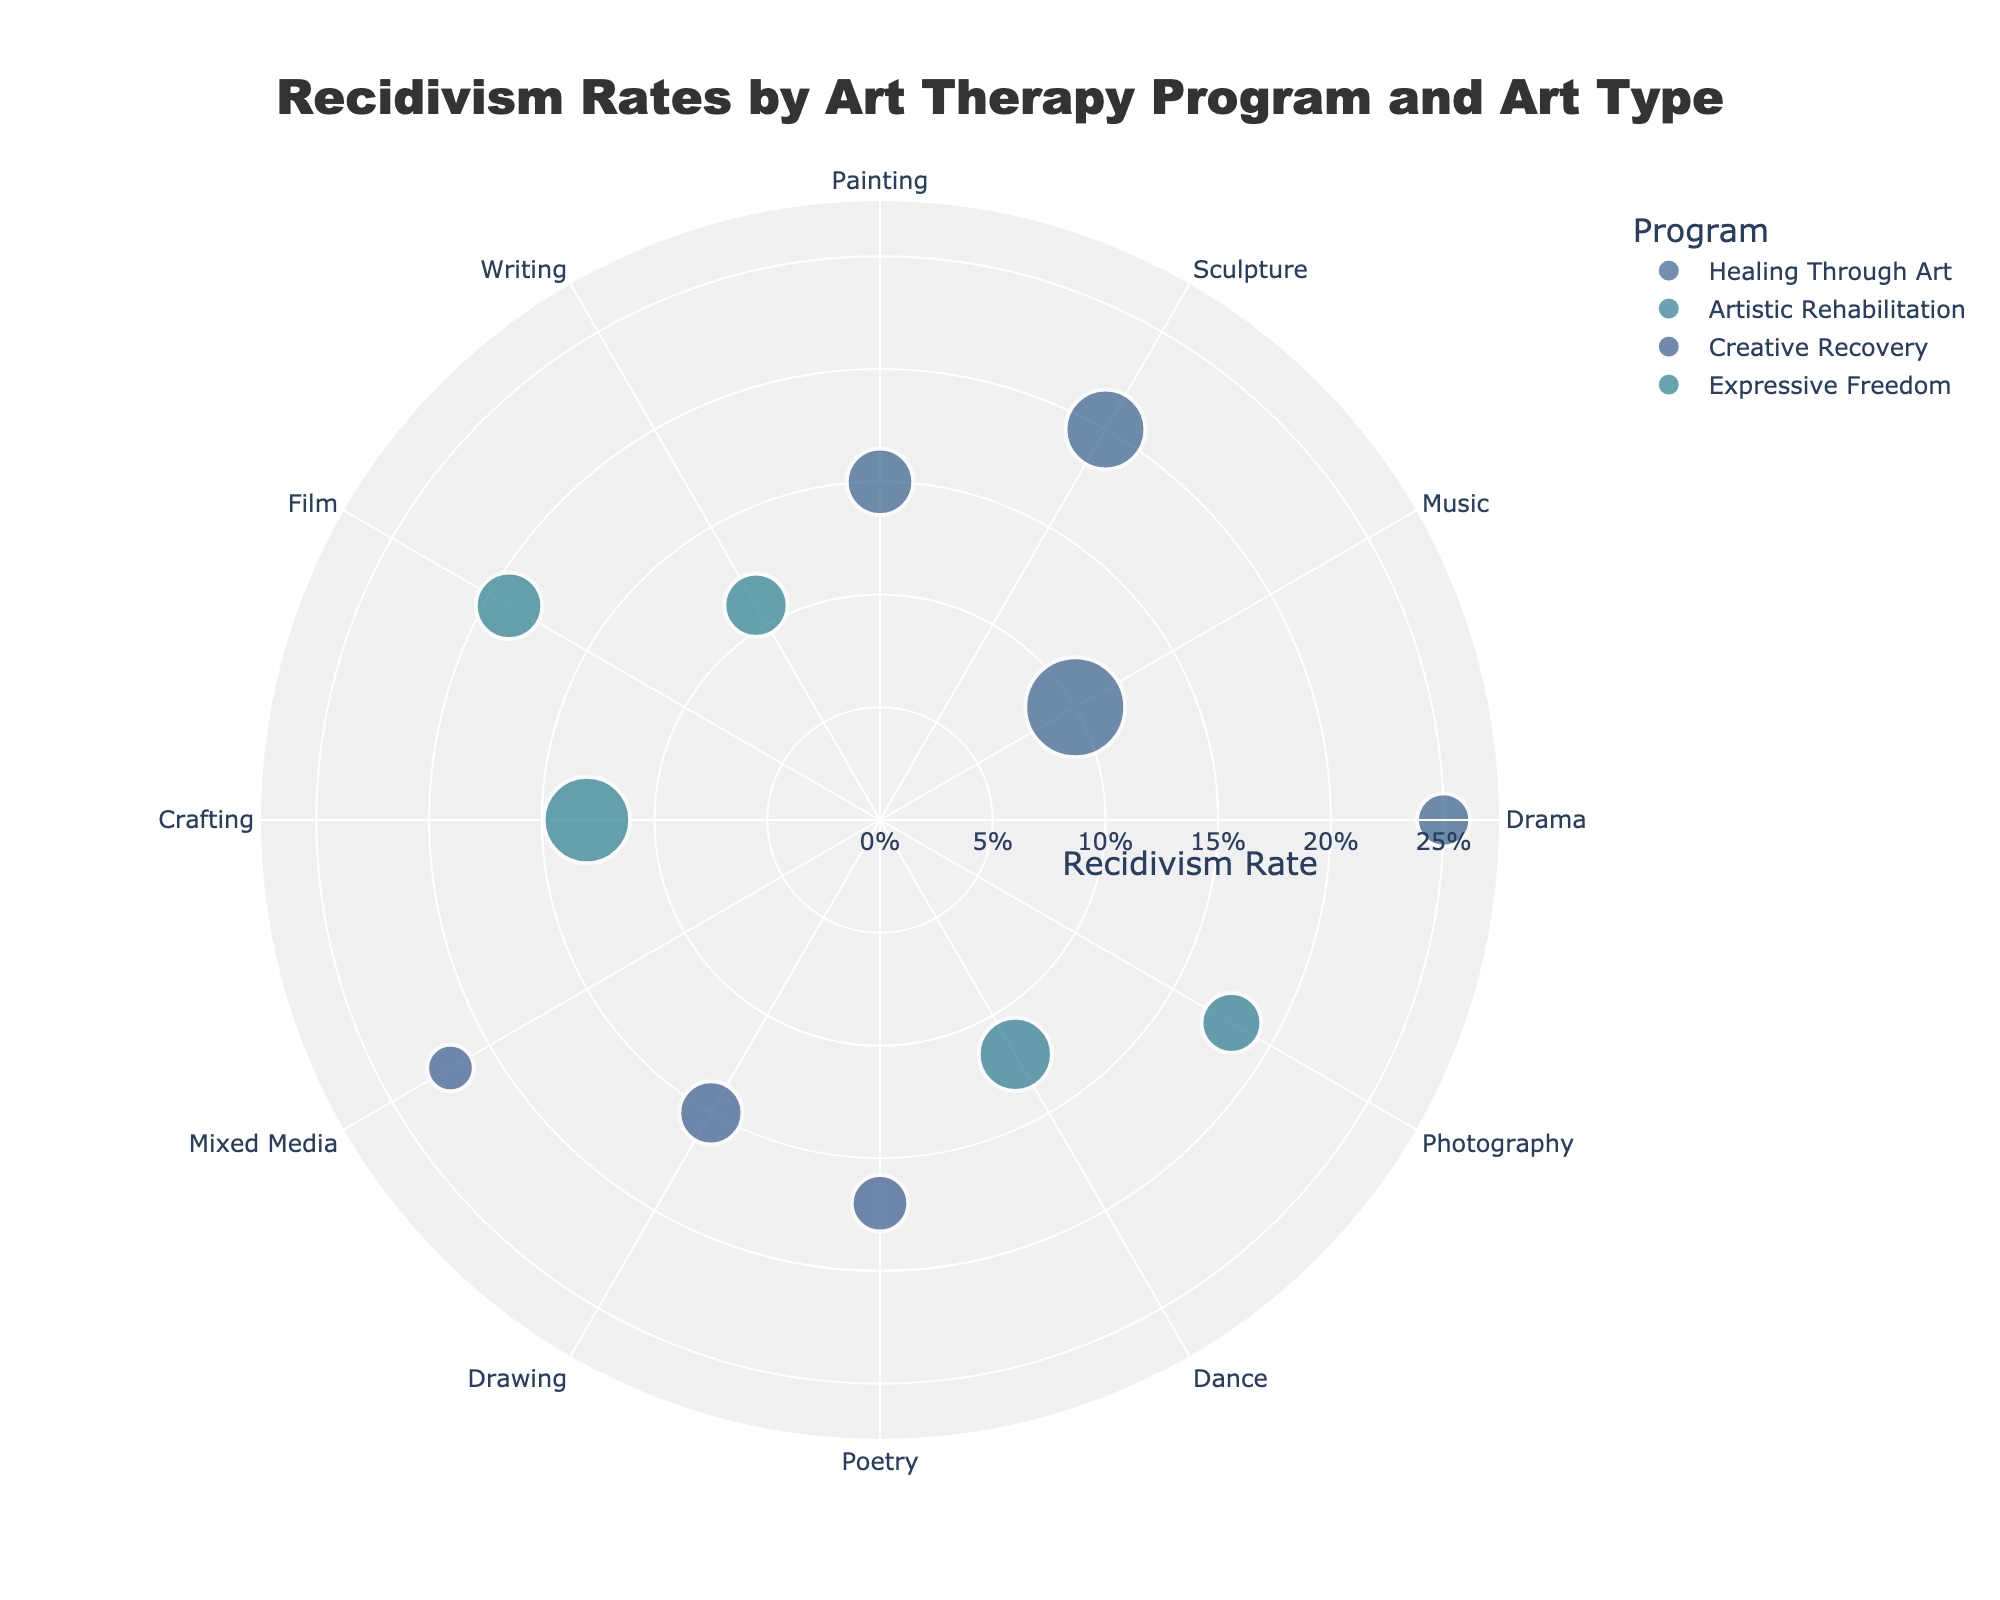What's the title of the figure? The title of the figure is prominently displayed at the top. It reads "Recidivism Rates by Art Therapy Program and Art Type."
Answer: Recidivism Rates by Art Therapy Program and Art Type Which program has the lowest recidivism rate for any art type? By looking at the markers' positions on the radial axis, the "Healing Through Art" program with Music has the lowest recidivism rate at 10%.
Answer: Healing Through Art with Music How many participants were in the "Expressive Freedom" program for Crafting? The marker size represents the number of participants. For Crafting under the "Expressive Freedom" program, hover over the large marker to reveal 130 participants.
Answer: 130 What's the average recidivism rate for the "Creative Recovery" program? Add the recidivism rates for all art types under "Creative Recovery" (Poetry: 17%, Drawing: 15%, Mixed Media: 22%) and then divide by the number of art types (3). Average = (17 + 15 + 22) / 3 = 54 / 3 = 18%.
Answer: 18% Which program has the highest average recidivism rate? Compare the average recidivism rates of all programs. "Healing Through Art" has the highest average, calculated as (15+20+10+25) / 4 = 17.5%.
Answer: Healing Through Art What is the difference in recidivism rates between "Photography" and "Painting"? Subtract the recidivism rate of Photography (18%) from the recidivism rate of Painting (15%). Difference = 18% - 15% = 3%.
Answer: 3% Which art type in "Artistic Rehabilitation" has the lowest recidivism rate? By looking at the positions, Dance under "Artistic Rehabilitation" has the lowest recidivism rate at 12%.
Answer: Dance How many different art types are represented in the "Healing Through Art" program? Count the distinct markers for "Healing Through Art". There are four: Painting, Sculpture, Music, Drama.
Answer: 4 Which two programs have the closest recidivism rates for their respective lowest art types? Identify the lowest recidivism rates for each program and compare the closest ones. "Healing Through Art" with Music (10%) and "Expressive Freedom" with Writing (11%) are the closest.
Answer: Healing Through Art with Music and Expressive Freedom with Writing Is there any art type that appears in more than one program? By examining the theta values (art types) across programs, you can see that each art type is unique to its program. For example, Poetry only appears in "Creative Recovery".
Answer: No 